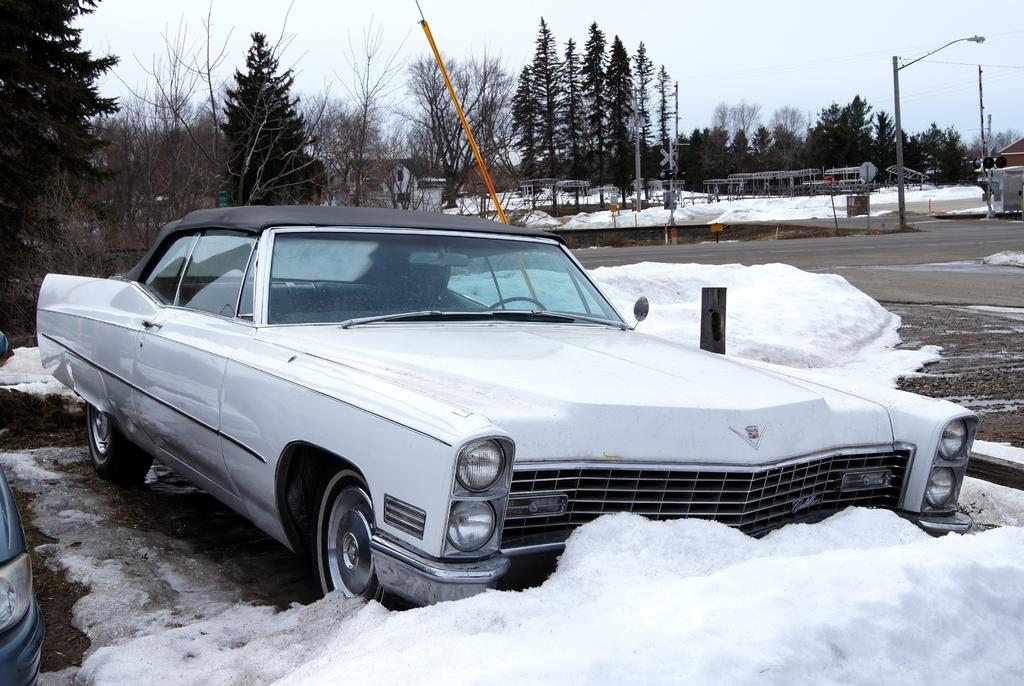What is the main subject of the image? There is a car in the image. What is the car's location in relation to the snow? The car is in front of the snow. What type of natural environment is visible in the image? There are trees visible in the image. What is visible in the background of the image? The sky is visible in the image. What structures can be seen at the top of the image? There are poles at the top of the image. What type of humor can be seen in the image? There is no humor present in the image; it is a scene of a car in front of snow with trees, sky, and poles visible. 